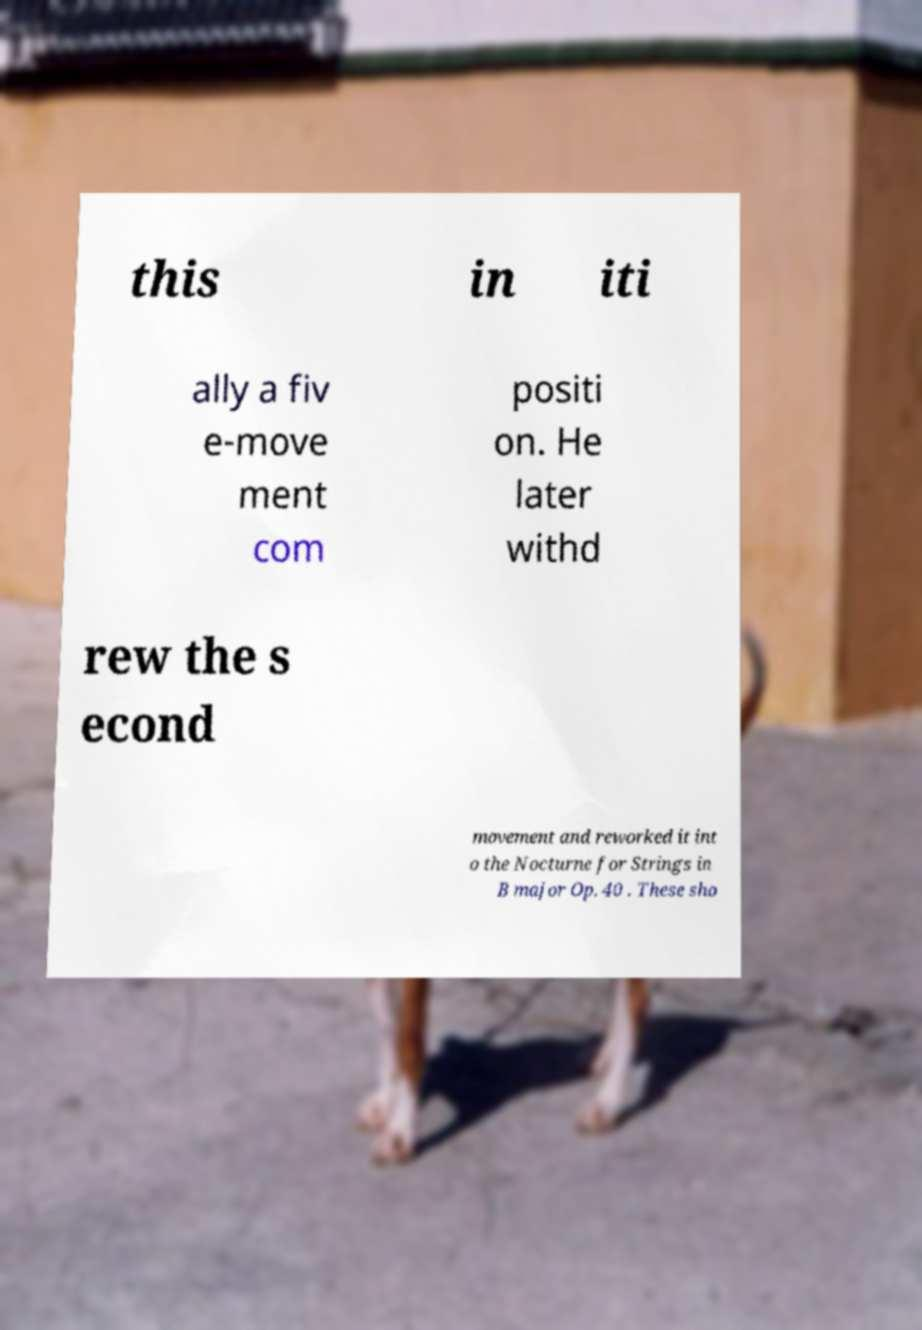Can you accurately transcribe the text from the provided image for me? this in iti ally a fiv e-move ment com positi on. He later withd rew the s econd movement and reworked it int o the Nocturne for Strings in B major Op. 40 . These sho 